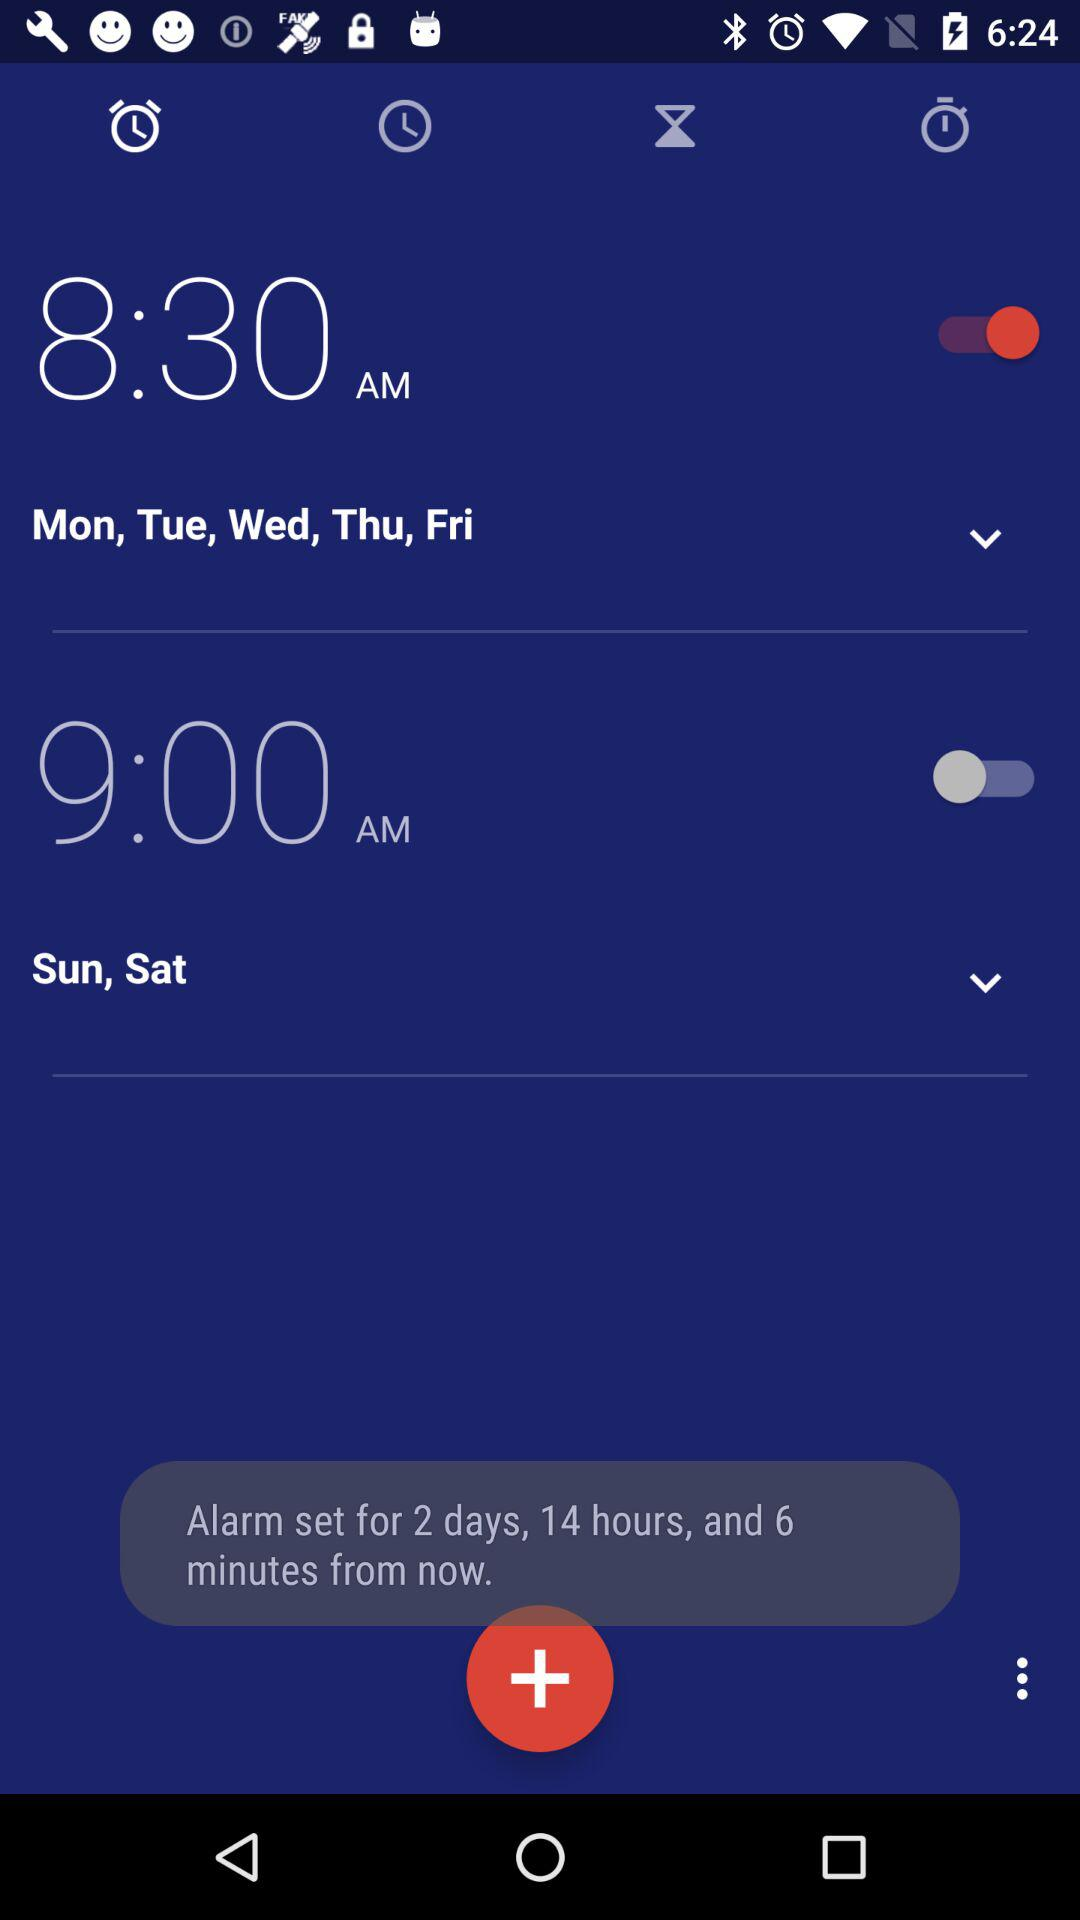What is the set alarm time? The set alarm times are 8:30 a.m. and 9:00 a.m. 